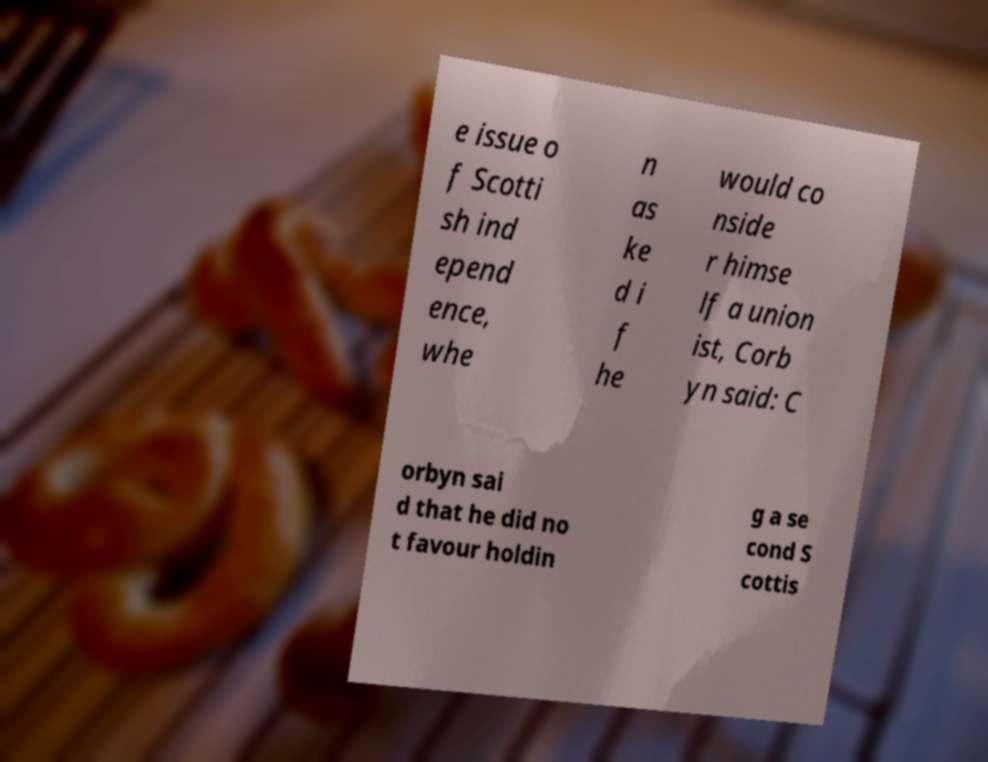Could you assist in decoding the text presented in this image and type it out clearly? e issue o f Scotti sh ind epend ence, whe n as ke d i f he would co nside r himse lf a union ist, Corb yn said: C orbyn sai d that he did no t favour holdin g a se cond S cottis 